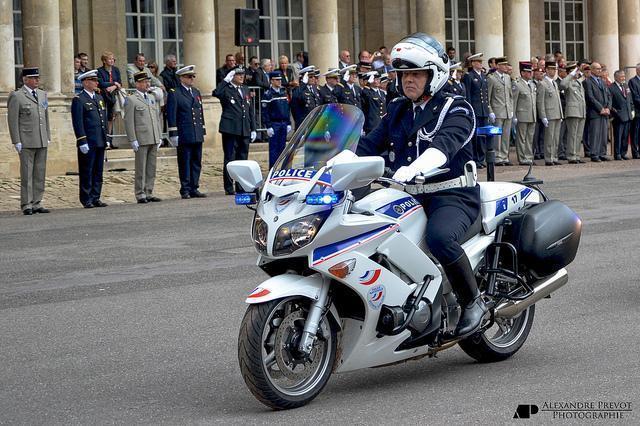Who pays this man's salary?
Indicate the correct response and explain using: 'Answer: answer
Rationale: rationale.'
Options: Private company, government, religious institution, private individual. Answer: government.
Rationale: People who are charged with keeping the peace in their communities are paid through taxes paid by those communities. 